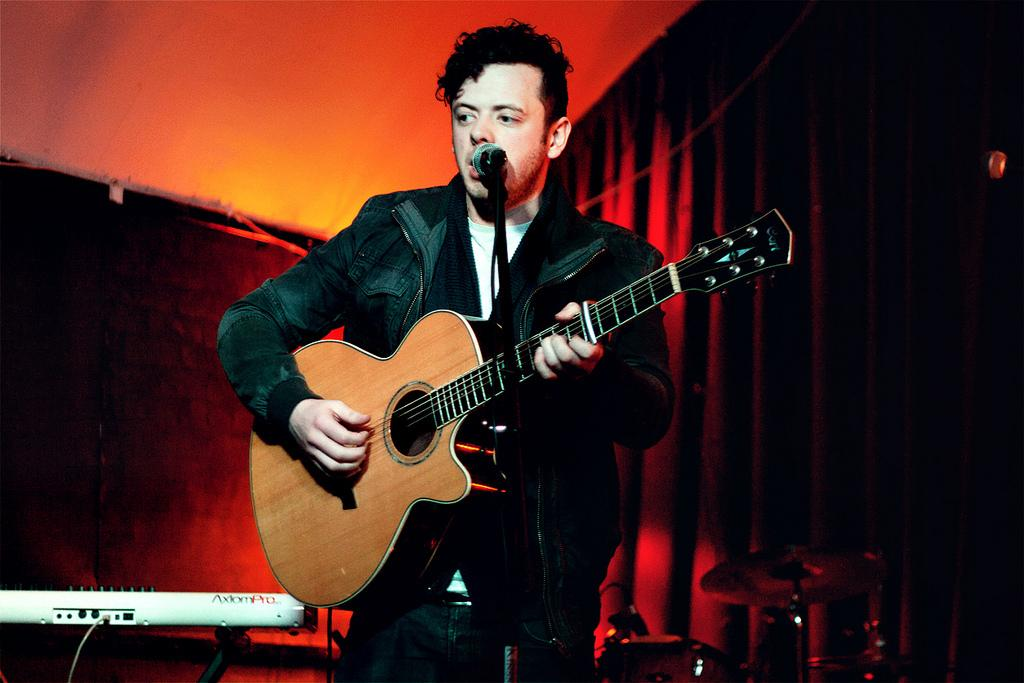Who is the main subject in the image? There is a boy in the image. What is the boy wearing? The boy is wearing a jacket. What activity is the boy engaged in? The boy is playing a guitar and singing into a microphone. Are there any other musicians in the image? Yes, there is a band behind the boy. What musical instrument can be seen in the image besides the guitar? There is a piano with a stand in the image. What can be seen in the background of the image? There is a red curtain in the background. What type of amusement park ride is visible in the image? There is no amusement park ride present in the image. What action is the boy taking with the net in the image? There is no net present in the image, and the boy is playing a guitar and singing into a microphone. 